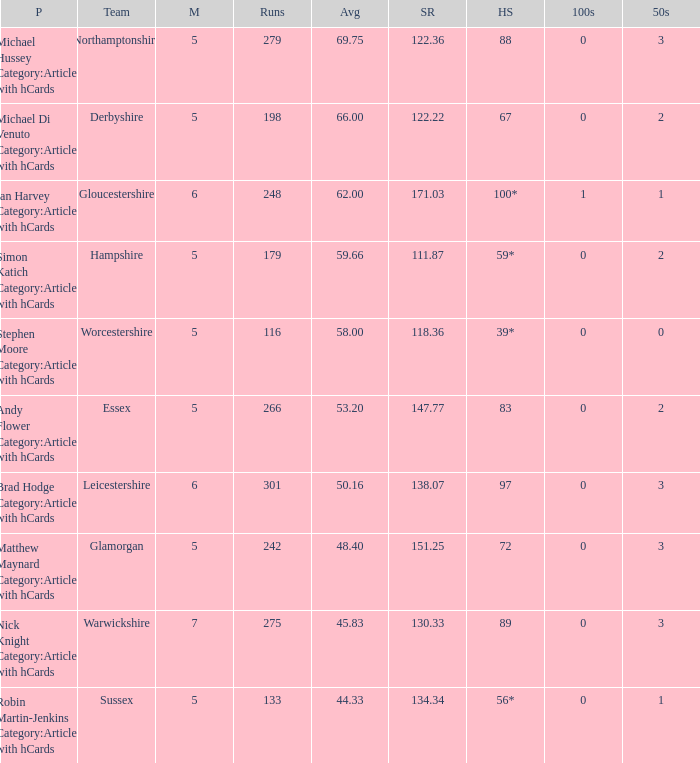I'm looking to parse the entire table for insights. Could you assist me with that? {'header': ['P', 'Team', 'M', 'Runs', 'Avg', 'SR', 'HS', '100s', '50s'], 'rows': [['Michael Hussey Category:Articles with hCards', 'Northamptonshire', '5', '279', '69.75', '122.36', '88', '0', '3'], ['Michael Di Venuto Category:Articles with hCards', 'Derbyshire', '5', '198', '66.00', '122.22', '67', '0', '2'], ['Ian Harvey Category:Articles with hCards', 'Gloucestershire', '6', '248', '62.00', '171.03', '100*', '1', '1'], ['Simon Katich Category:Articles with hCards', 'Hampshire', '5', '179', '59.66', '111.87', '59*', '0', '2'], ['Stephen Moore Category:Articles with hCards', 'Worcestershire', '5', '116', '58.00', '118.36', '39*', '0', '0'], ['Andy Flower Category:Articles with hCards', 'Essex', '5', '266', '53.20', '147.77', '83', '0', '2'], ['Brad Hodge Category:Articles with hCards', 'Leicestershire', '6', '301', '50.16', '138.07', '97', '0', '3'], ['Matthew Maynard Category:Articles with hCards', 'Glamorgan', '5', '242', '48.40', '151.25', '72', '0', '3'], ['Nick Knight Category:Articles with hCards', 'Warwickshire', '7', '275', '45.83', '130.33', '89', '0', '3'], ['Robin Martin-Jenkins Category:Articles with hCards', 'Sussex', '5', '133', '44.33', '134.34', '56*', '0', '1']]} What is the team Sussex' highest score? 56*. 